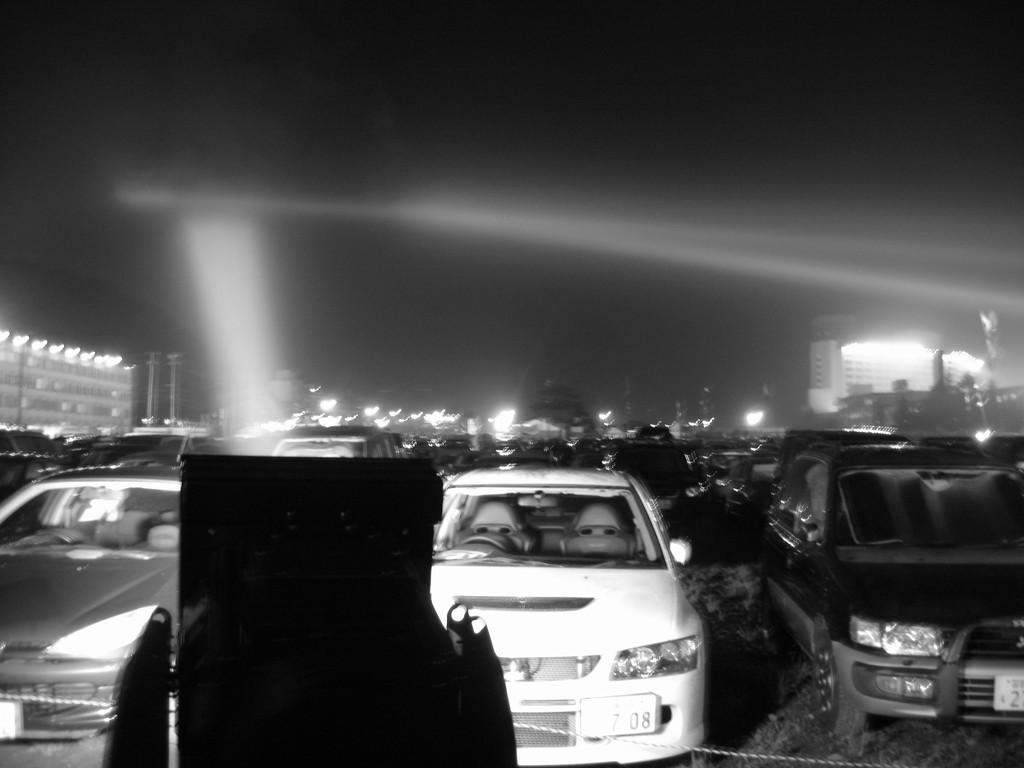What can be seen on the road in the image? There are cars on the road in the image. What is the condition of the sky in the image? The sky appears to be dark in the image. What type of territory is depicted in the image? There is no territory depicted in the image; it features cars on a road and a dark sky. What kind of plantation can be seen in the image? There is no plantation present in the image. 